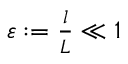Convert formula to latex. <formula><loc_0><loc_0><loc_500><loc_500>\begin{array} { r } { \varepsilon \colon = \frac { l } { L } \ll 1 } \end{array}</formula> 